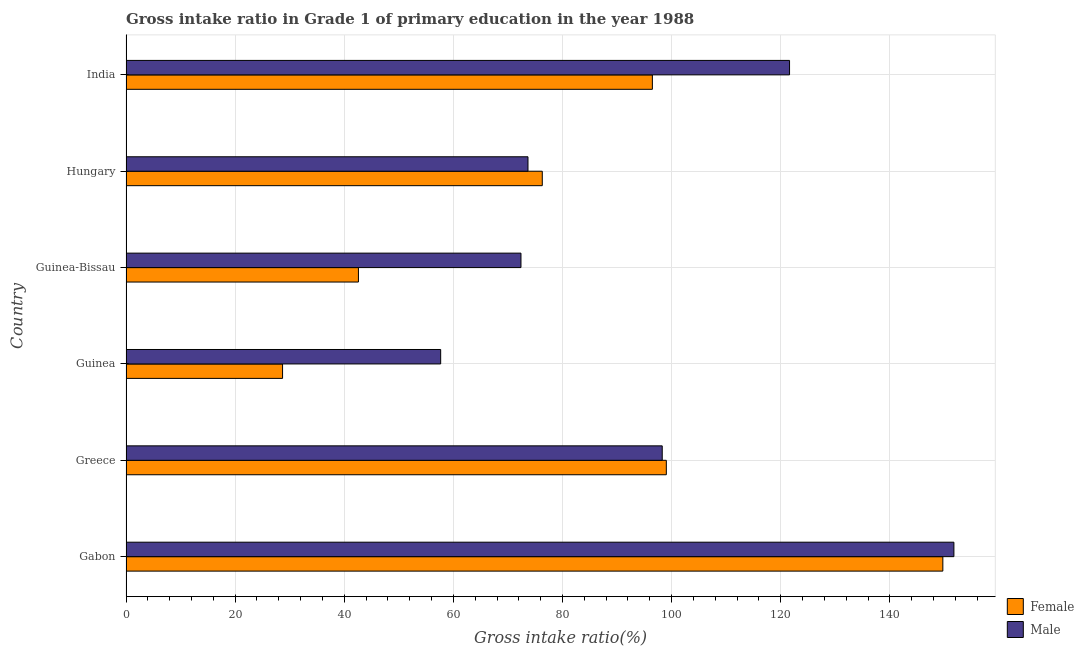How many groups of bars are there?
Your answer should be compact. 6. What is the label of the 2nd group of bars from the top?
Give a very brief answer. Hungary. What is the gross intake ratio(female) in Guinea?
Give a very brief answer. 28.69. Across all countries, what is the maximum gross intake ratio(male)?
Provide a succinct answer. 151.74. Across all countries, what is the minimum gross intake ratio(male)?
Offer a terse response. 57.67. In which country was the gross intake ratio(female) maximum?
Ensure brevity in your answer.  Gabon. In which country was the gross intake ratio(female) minimum?
Offer a very short reply. Guinea. What is the total gross intake ratio(female) in the graph?
Make the answer very short. 492.8. What is the difference between the gross intake ratio(male) in Greece and that in India?
Ensure brevity in your answer.  -23.33. What is the difference between the gross intake ratio(female) in Guinea and the gross intake ratio(male) in Gabon?
Give a very brief answer. -123.05. What is the average gross intake ratio(male) per country?
Offer a terse response. 95.9. What is the difference between the gross intake ratio(male) and gross intake ratio(female) in Guinea?
Provide a short and direct response. 28.98. What is the ratio of the gross intake ratio(male) in Guinea to that in India?
Your response must be concise. 0.47. What is the difference between the highest and the second highest gross intake ratio(female)?
Offer a very short reply. 50.68. What is the difference between the highest and the lowest gross intake ratio(male)?
Your answer should be very brief. 94.07. What does the 1st bar from the top in Gabon represents?
Give a very brief answer. Male. Are all the bars in the graph horizontal?
Ensure brevity in your answer.  Yes. Are the values on the major ticks of X-axis written in scientific E-notation?
Make the answer very short. No. Does the graph contain grids?
Offer a terse response. Yes. How many legend labels are there?
Keep it short and to the point. 2. How are the legend labels stacked?
Your answer should be compact. Vertical. What is the title of the graph?
Provide a short and direct response. Gross intake ratio in Grade 1 of primary education in the year 1988. What is the label or title of the X-axis?
Give a very brief answer. Gross intake ratio(%). What is the Gross intake ratio(%) of Female in Gabon?
Keep it short and to the point. 149.71. What is the Gross intake ratio(%) of Male in Gabon?
Keep it short and to the point. 151.74. What is the Gross intake ratio(%) in Female in Greece?
Provide a short and direct response. 99.03. What is the Gross intake ratio(%) of Male in Greece?
Ensure brevity in your answer.  98.28. What is the Gross intake ratio(%) in Female in Guinea?
Your response must be concise. 28.69. What is the Gross intake ratio(%) in Male in Guinea?
Offer a very short reply. 57.67. What is the Gross intake ratio(%) in Female in Guinea-Bissau?
Keep it short and to the point. 42.6. What is the Gross intake ratio(%) of Male in Guinea-Bissau?
Ensure brevity in your answer.  72.39. What is the Gross intake ratio(%) of Female in Hungary?
Offer a very short reply. 76.29. What is the Gross intake ratio(%) of Male in Hungary?
Keep it short and to the point. 73.68. What is the Gross intake ratio(%) in Female in India?
Offer a very short reply. 96.47. What is the Gross intake ratio(%) of Male in India?
Provide a succinct answer. 121.62. Across all countries, what is the maximum Gross intake ratio(%) of Female?
Your response must be concise. 149.71. Across all countries, what is the maximum Gross intake ratio(%) of Male?
Provide a short and direct response. 151.74. Across all countries, what is the minimum Gross intake ratio(%) of Female?
Keep it short and to the point. 28.69. Across all countries, what is the minimum Gross intake ratio(%) in Male?
Your answer should be very brief. 57.67. What is the total Gross intake ratio(%) of Female in the graph?
Provide a short and direct response. 492.8. What is the total Gross intake ratio(%) of Male in the graph?
Make the answer very short. 575.37. What is the difference between the Gross intake ratio(%) in Female in Gabon and that in Greece?
Ensure brevity in your answer.  50.68. What is the difference between the Gross intake ratio(%) of Male in Gabon and that in Greece?
Ensure brevity in your answer.  53.46. What is the difference between the Gross intake ratio(%) of Female in Gabon and that in Guinea?
Offer a terse response. 121.02. What is the difference between the Gross intake ratio(%) of Male in Gabon and that in Guinea?
Your response must be concise. 94.07. What is the difference between the Gross intake ratio(%) in Female in Gabon and that in Guinea-Bissau?
Provide a succinct answer. 107.11. What is the difference between the Gross intake ratio(%) of Male in Gabon and that in Guinea-Bissau?
Your response must be concise. 79.35. What is the difference between the Gross intake ratio(%) of Female in Gabon and that in Hungary?
Offer a terse response. 73.42. What is the difference between the Gross intake ratio(%) in Male in Gabon and that in Hungary?
Provide a short and direct response. 78.06. What is the difference between the Gross intake ratio(%) of Female in Gabon and that in India?
Your answer should be compact. 53.24. What is the difference between the Gross intake ratio(%) of Male in Gabon and that in India?
Make the answer very short. 30.12. What is the difference between the Gross intake ratio(%) in Female in Greece and that in Guinea?
Your response must be concise. 70.34. What is the difference between the Gross intake ratio(%) of Male in Greece and that in Guinea?
Your answer should be very brief. 40.61. What is the difference between the Gross intake ratio(%) of Female in Greece and that in Guinea-Bissau?
Make the answer very short. 56.43. What is the difference between the Gross intake ratio(%) in Male in Greece and that in Guinea-Bissau?
Provide a succinct answer. 25.89. What is the difference between the Gross intake ratio(%) in Female in Greece and that in Hungary?
Make the answer very short. 22.74. What is the difference between the Gross intake ratio(%) in Male in Greece and that in Hungary?
Provide a succinct answer. 24.61. What is the difference between the Gross intake ratio(%) in Female in Greece and that in India?
Give a very brief answer. 2.56. What is the difference between the Gross intake ratio(%) in Male in Greece and that in India?
Offer a very short reply. -23.33. What is the difference between the Gross intake ratio(%) of Female in Guinea and that in Guinea-Bissau?
Ensure brevity in your answer.  -13.91. What is the difference between the Gross intake ratio(%) of Male in Guinea and that in Guinea-Bissau?
Offer a very short reply. -14.72. What is the difference between the Gross intake ratio(%) of Female in Guinea and that in Hungary?
Make the answer very short. -47.6. What is the difference between the Gross intake ratio(%) of Male in Guinea and that in Hungary?
Provide a short and direct response. -16. What is the difference between the Gross intake ratio(%) of Female in Guinea and that in India?
Give a very brief answer. -67.78. What is the difference between the Gross intake ratio(%) of Male in Guinea and that in India?
Give a very brief answer. -63.94. What is the difference between the Gross intake ratio(%) of Female in Guinea-Bissau and that in Hungary?
Your answer should be very brief. -33.69. What is the difference between the Gross intake ratio(%) in Male in Guinea-Bissau and that in Hungary?
Keep it short and to the point. -1.29. What is the difference between the Gross intake ratio(%) in Female in Guinea-Bissau and that in India?
Offer a very short reply. -53.87. What is the difference between the Gross intake ratio(%) in Male in Guinea-Bissau and that in India?
Provide a succinct answer. -49.23. What is the difference between the Gross intake ratio(%) in Female in Hungary and that in India?
Your answer should be compact. -20.18. What is the difference between the Gross intake ratio(%) in Male in Hungary and that in India?
Provide a short and direct response. -47.94. What is the difference between the Gross intake ratio(%) of Female in Gabon and the Gross intake ratio(%) of Male in Greece?
Offer a terse response. 51.43. What is the difference between the Gross intake ratio(%) of Female in Gabon and the Gross intake ratio(%) of Male in Guinea?
Your answer should be very brief. 92.04. What is the difference between the Gross intake ratio(%) in Female in Gabon and the Gross intake ratio(%) in Male in Guinea-Bissau?
Ensure brevity in your answer.  77.32. What is the difference between the Gross intake ratio(%) of Female in Gabon and the Gross intake ratio(%) of Male in Hungary?
Offer a terse response. 76.04. What is the difference between the Gross intake ratio(%) in Female in Gabon and the Gross intake ratio(%) in Male in India?
Give a very brief answer. 28.1. What is the difference between the Gross intake ratio(%) in Female in Greece and the Gross intake ratio(%) in Male in Guinea?
Offer a very short reply. 41.36. What is the difference between the Gross intake ratio(%) in Female in Greece and the Gross intake ratio(%) in Male in Guinea-Bissau?
Provide a succinct answer. 26.64. What is the difference between the Gross intake ratio(%) in Female in Greece and the Gross intake ratio(%) in Male in Hungary?
Keep it short and to the point. 25.35. What is the difference between the Gross intake ratio(%) of Female in Greece and the Gross intake ratio(%) of Male in India?
Keep it short and to the point. -22.59. What is the difference between the Gross intake ratio(%) in Female in Guinea and the Gross intake ratio(%) in Male in Guinea-Bissau?
Your response must be concise. -43.7. What is the difference between the Gross intake ratio(%) of Female in Guinea and the Gross intake ratio(%) of Male in Hungary?
Keep it short and to the point. -44.98. What is the difference between the Gross intake ratio(%) of Female in Guinea and the Gross intake ratio(%) of Male in India?
Your response must be concise. -92.92. What is the difference between the Gross intake ratio(%) of Female in Guinea-Bissau and the Gross intake ratio(%) of Male in Hungary?
Your answer should be compact. -31.08. What is the difference between the Gross intake ratio(%) in Female in Guinea-Bissau and the Gross intake ratio(%) in Male in India?
Make the answer very short. -79.02. What is the difference between the Gross intake ratio(%) of Female in Hungary and the Gross intake ratio(%) of Male in India?
Make the answer very short. -45.32. What is the average Gross intake ratio(%) in Female per country?
Keep it short and to the point. 82.13. What is the average Gross intake ratio(%) in Male per country?
Give a very brief answer. 95.9. What is the difference between the Gross intake ratio(%) in Female and Gross intake ratio(%) in Male in Gabon?
Give a very brief answer. -2.03. What is the difference between the Gross intake ratio(%) in Female and Gross intake ratio(%) in Male in Greece?
Offer a very short reply. 0.75. What is the difference between the Gross intake ratio(%) of Female and Gross intake ratio(%) of Male in Guinea?
Provide a succinct answer. -28.98. What is the difference between the Gross intake ratio(%) in Female and Gross intake ratio(%) in Male in Guinea-Bissau?
Give a very brief answer. -29.79. What is the difference between the Gross intake ratio(%) in Female and Gross intake ratio(%) in Male in Hungary?
Make the answer very short. 2.62. What is the difference between the Gross intake ratio(%) in Female and Gross intake ratio(%) in Male in India?
Give a very brief answer. -25.14. What is the ratio of the Gross intake ratio(%) in Female in Gabon to that in Greece?
Make the answer very short. 1.51. What is the ratio of the Gross intake ratio(%) in Male in Gabon to that in Greece?
Your answer should be compact. 1.54. What is the ratio of the Gross intake ratio(%) of Female in Gabon to that in Guinea?
Make the answer very short. 5.22. What is the ratio of the Gross intake ratio(%) in Male in Gabon to that in Guinea?
Keep it short and to the point. 2.63. What is the ratio of the Gross intake ratio(%) of Female in Gabon to that in Guinea-Bissau?
Provide a succinct answer. 3.51. What is the ratio of the Gross intake ratio(%) of Male in Gabon to that in Guinea-Bissau?
Your response must be concise. 2.1. What is the ratio of the Gross intake ratio(%) in Female in Gabon to that in Hungary?
Provide a succinct answer. 1.96. What is the ratio of the Gross intake ratio(%) of Male in Gabon to that in Hungary?
Make the answer very short. 2.06. What is the ratio of the Gross intake ratio(%) in Female in Gabon to that in India?
Give a very brief answer. 1.55. What is the ratio of the Gross intake ratio(%) in Male in Gabon to that in India?
Provide a short and direct response. 1.25. What is the ratio of the Gross intake ratio(%) of Female in Greece to that in Guinea?
Provide a short and direct response. 3.45. What is the ratio of the Gross intake ratio(%) of Male in Greece to that in Guinea?
Offer a terse response. 1.7. What is the ratio of the Gross intake ratio(%) in Female in Greece to that in Guinea-Bissau?
Offer a very short reply. 2.32. What is the ratio of the Gross intake ratio(%) of Male in Greece to that in Guinea-Bissau?
Keep it short and to the point. 1.36. What is the ratio of the Gross intake ratio(%) of Female in Greece to that in Hungary?
Ensure brevity in your answer.  1.3. What is the ratio of the Gross intake ratio(%) of Male in Greece to that in Hungary?
Offer a very short reply. 1.33. What is the ratio of the Gross intake ratio(%) in Female in Greece to that in India?
Make the answer very short. 1.03. What is the ratio of the Gross intake ratio(%) in Male in Greece to that in India?
Provide a succinct answer. 0.81. What is the ratio of the Gross intake ratio(%) of Female in Guinea to that in Guinea-Bissau?
Give a very brief answer. 0.67. What is the ratio of the Gross intake ratio(%) of Male in Guinea to that in Guinea-Bissau?
Your answer should be very brief. 0.8. What is the ratio of the Gross intake ratio(%) of Female in Guinea to that in Hungary?
Ensure brevity in your answer.  0.38. What is the ratio of the Gross intake ratio(%) of Male in Guinea to that in Hungary?
Ensure brevity in your answer.  0.78. What is the ratio of the Gross intake ratio(%) in Female in Guinea to that in India?
Make the answer very short. 0.3. What is the ratio of the Gross intake ratio(%) of Male in Guinea to that in India?
Ensure brevity in your answer.  0.47. What is the ratio of the Gross intake ratio(%) in Female in Guinea-Bissau to that in Hungary?
Make the answer very short. 0.56. What is the ratio of the Gross intake ratio(%) of Male in Guinea-Bissau to that in Hungary?
Keep it short and to the point. 0.98. What is the ratio of the Gross intake ratio(%) in Female in Guinea-Bissau to that in India?
Your response must be concise. 0.44. What is the ratio of the Gross intake ratio(%) of Male in Guinea-Bissau to that in India?
Your response must be concise. 0.6. What is the ratio of the Gross intake ratio(%) of Female in Hungary to that in India?
Your answer should be compact. 0.79. What is the ratio of the Gross intake ratio(%) in Male in Hungary to that in India?
Provide a succinct answer. 0.61. What is the difference between the highest and the second highest Gross intake ratio(%) of Female?
Make the answer very short. 50.68. What is the difference between the highest and the second highest Gross intake ratio(%) of Male?
Offer a terse response. 30.12. What is the difference between the highest and the lowest Gross intake ratio(%) of Female?
Ensure brevity in your answer.  121.02. What is the difference between the highest and the lowest Gross intake ratio(%) of Male?
Provide a succinct answer. 94.07. 